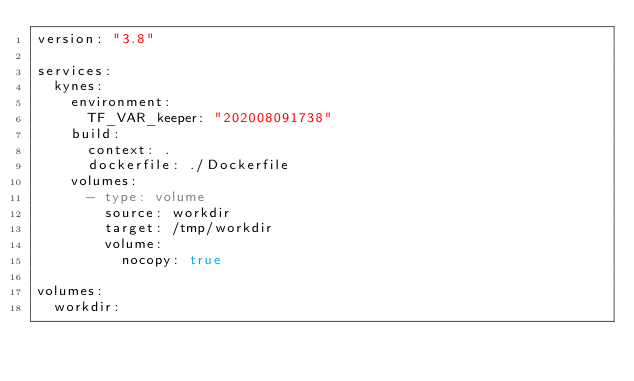<code> <loc_0><loc_0><loc_500><loc_500><_YAML_>version: "3.8"

services:
  kynes:
    environment:
      TF_VAR_keeper: "202008091738"
    build:
      context: .
      dockerfile: ./Dockerfile
    volumes:
      - type: volume
        source: workdir
        target: /tmp/workdir
        volume:
          nocopy: true

volumes:
  workdir:</code> 